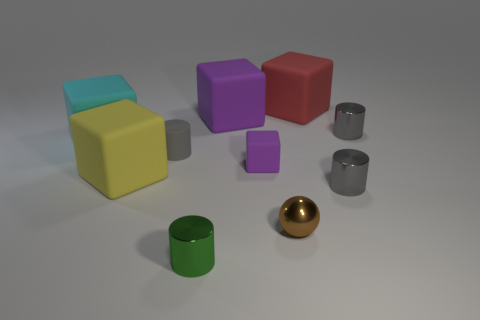Subtract all gray balls. How many gray cylinders are left? 3 Subtract all cyan matte blocks. How many blocks are left? 4 Subtract all cylinders. How many objects are left? 6 Subtract all cyan blocks. How many blocks are left? 4 Subtract all gray matte blocks. Subtract all large purple things. How many objects are left? 9 Add 3 red rubber things. How many red rubber things are left? 4 Add 4 cylinders. How many cylinders exist? 8 Subtract 0 brown cubes. How many objects are left? 10 Subtract all green blocks. Subtract all cyan spheres. How many blocks are left? 5 